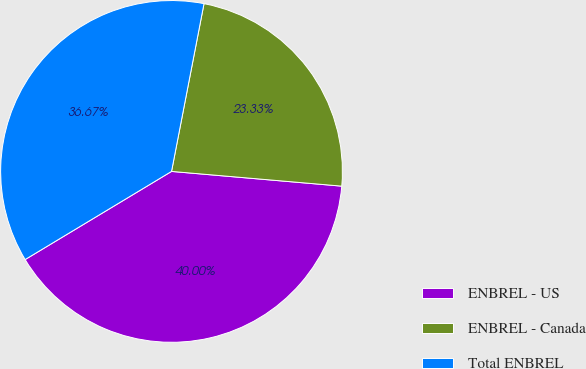Convert chart to OTSL. <chart><loc_0><loc_0><loc_500><loc_500><pie_chart><fcel>ENBREL - US<fcel>ENBREL - Canada<fcel>Total ENBREL<nl><fcel>40.0%<fcel>23.33%<fcel>36.67%<nl></chart> 